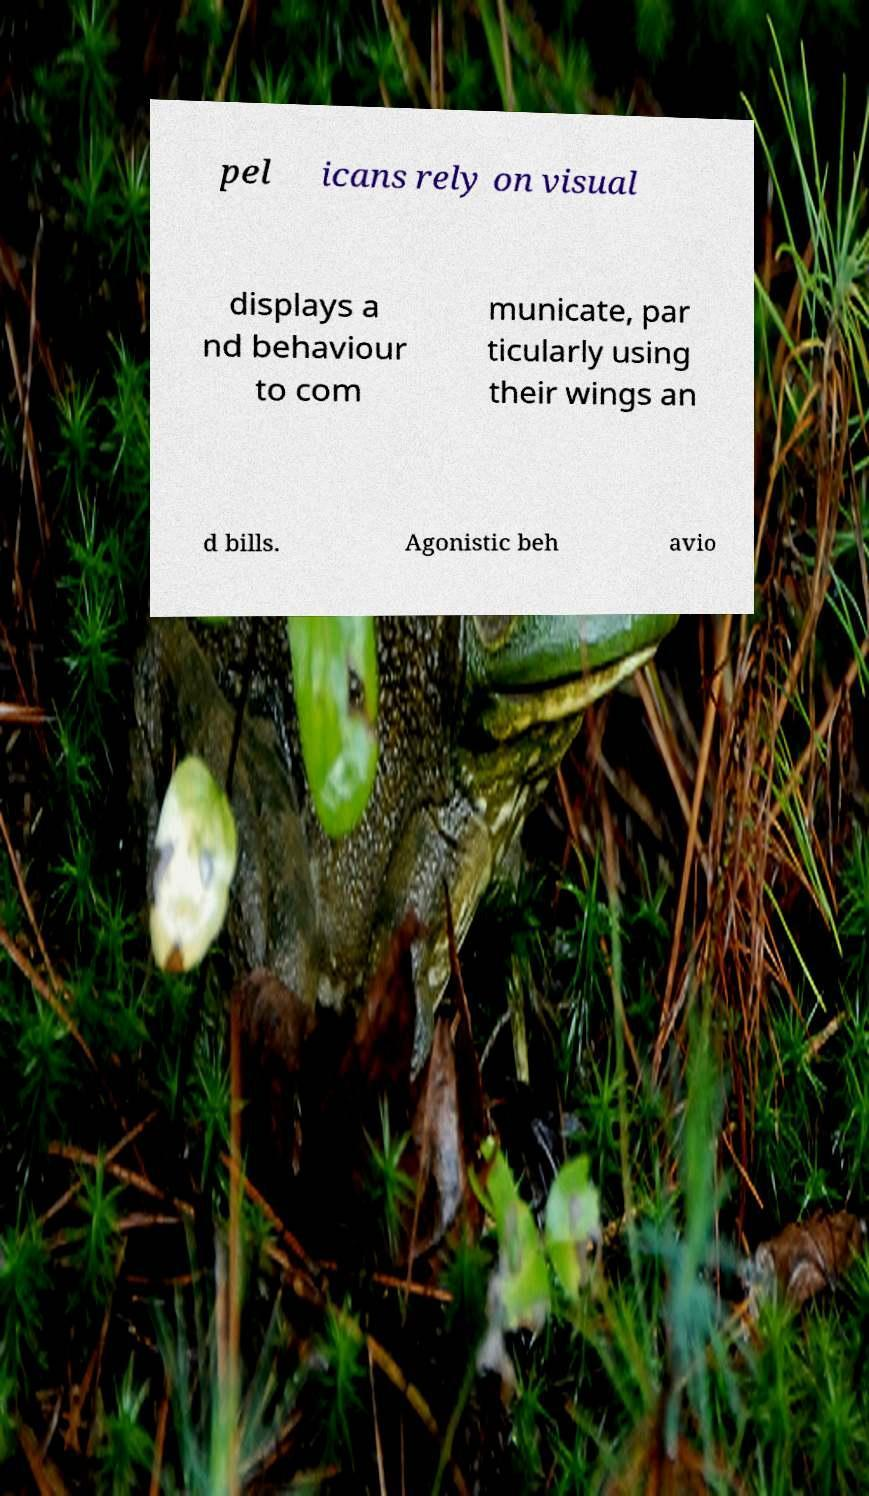There's text embedded in this image that I need extracted. Can you transcribe it verbatim? pel icans rely on visual displays a nd behaviour to com municate, par ticularly using their wings an d bills. Agonistic beh avio 